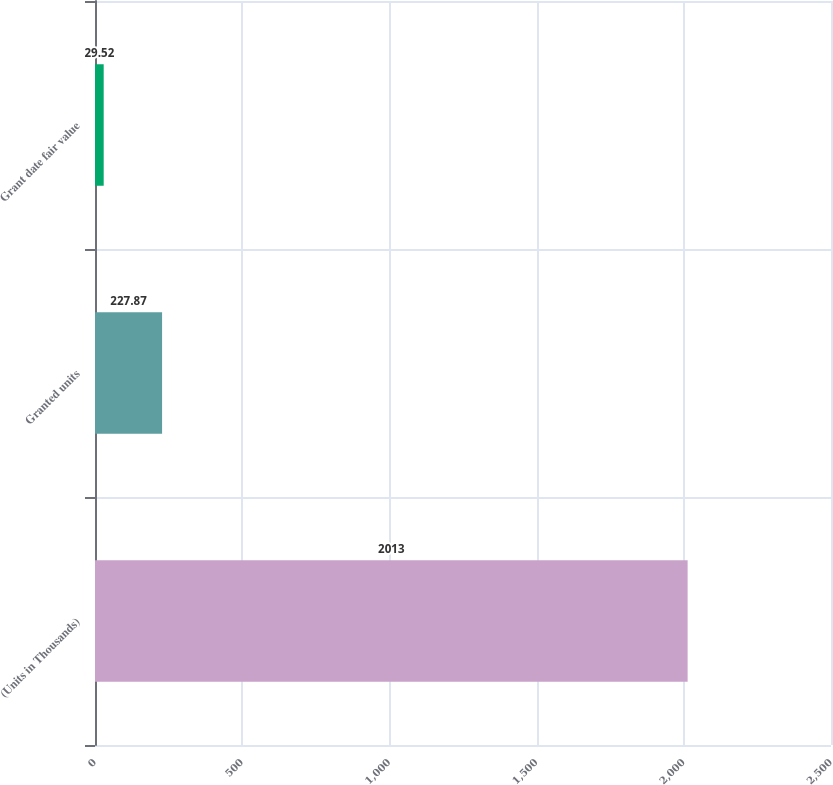<chart> <loc_0><loc_0><loc_500><loc_500><bar_chart><fcel>(Units in Thousands)<fcel>Granted units<fcel>Grant date fair value<nl><fcel>2013<fcel>227.87<fcel>29.52<nl></chart> 